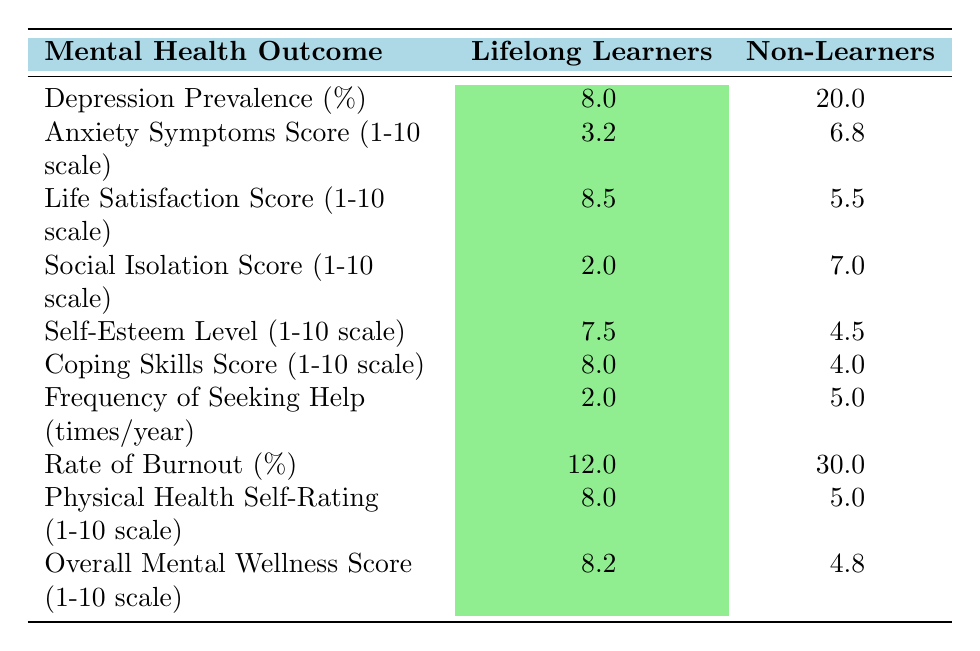What is the depression prevalence percentage among lifelong learners? The table states that the depression prevalence among lifelong learners is listed as 8%.
Answer: 8% What is the anxiety symptoms score for non-learners? The anxiety symptoms score for non-learners is given in the table as 6.8 on a 1-10 scale.
Answer: 6.8 What is the difference in life satisfaction scores between lifelong learners and non-learners? Lifelong learners have a life satisfaction score of 8.5, while non-learners have 5.5. The difference is 8.5 - 5.5 = 3.0.
Answer: 3.0 Is the rate of burnout higher among non-learners than lifelong learners? The table shows that the rate of burnout for lifelong learners is 12%, while for non-learners it is 30%. This means that non-learners have a higher rate of burnout.
Answer: Yes What is the average self-esteem level for lifelong learners and non-learners combined? The self-esteem level for lifelong learners is 7.5 and for non-learners is 4.5. To find the average, add the two values (7.5 + 4.5 = 12) and divide by 2, giving an average of 12/2 = 6.0.
Answer: 6.0 How many more times per year do non-learners typically seek help compared to lifelong learners? Lifelong learners seek help 2 times per year, while non-learners seek help 5 times a year. The difference is 5 - 2 = 3.
Answer: 3 What is the overall mental wellness score for non-learners? According to the table, non-learners have an overall mental wellness score of 4.8.
Answer: 4.8 Is it true that lifelong learners have a higher coping skills score than non-learners? Yes, lifelong learners have a coping skills score of 8.0 while non-learners have a score of 4.0, indicating that lifelong learners have a higher score.
Answer: Yes What is the total score for both social isolation and physical health self-rating for lifelong learners? The social isolation score for lifelong learners is 2.0, and the physical health self-rating is 8.0. Adding these together gives 2.0 + 8.0 = 10.0.
Answer: 10.0 For lifelong learners, how much lower is the anxiety symptoms score compared to their life satisfaction score? Lifelong learners have an anxiety symptoms score of 3.2 and a life satisfaction score of 8.5. The difference is 8.5 - 3.2 = 5.3.
Answer: 5.3 